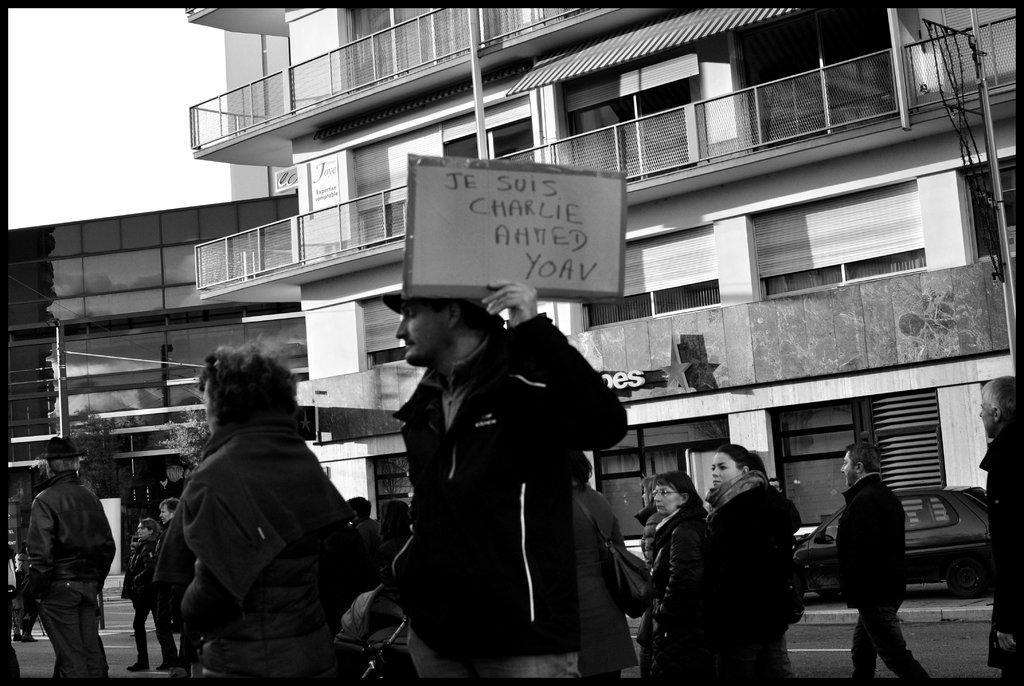Can you describe this image briefly? In this image, we can see a group of people wearing clothes and standing in front of the building. There is a person in the middle of the image holding a placard with his hand. There is a sky in the top left of the image. 